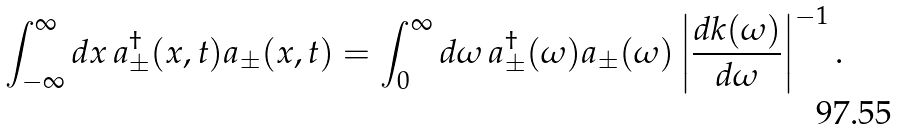Convert formula to latex. <formula><loc_0><loc_0><loc_500><loc_500>\int ^ { \infty } _ { - \infty } d x \, a _ { \pm } ^ { \dag } ( x , t ) a _ { \pm } ( x , t ) = \int _ { 0 } ^ { \infty } d \omega \, a _ { \pm } ^ { \dag } ( \omega ) a _ { \pm } ( \omega ) \left | \frac { d k ( \omega ) } { d \omega } \right | ^ { - 1 } .</formula> 